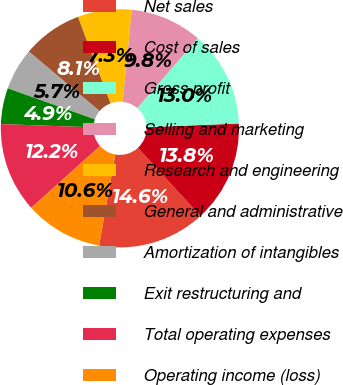Convert chart to OTSL. <chart><loc_0><loc_0><loc_500><loc_500><pie_chart><fcel>Net sales<fcel>Cost of sales<fcel>Gross profit<fcel>Selling and marketing<fcel>Research and engineering<fcel>General and administrative<fcel>Amortization of intangibles<fcel>Exit restructuring and<fcel>Total operating expenses<fcel>Operating income (loss)<nl><fcel>14.63%<fcel>13.82%<fcel>13.01%<fcel>9.76%<fcel>7.32%<fcel>8.13%<fcel>5.69%<fcel>4.88%<fcel>12.2%<fcel>10.57%<nl></chart> 